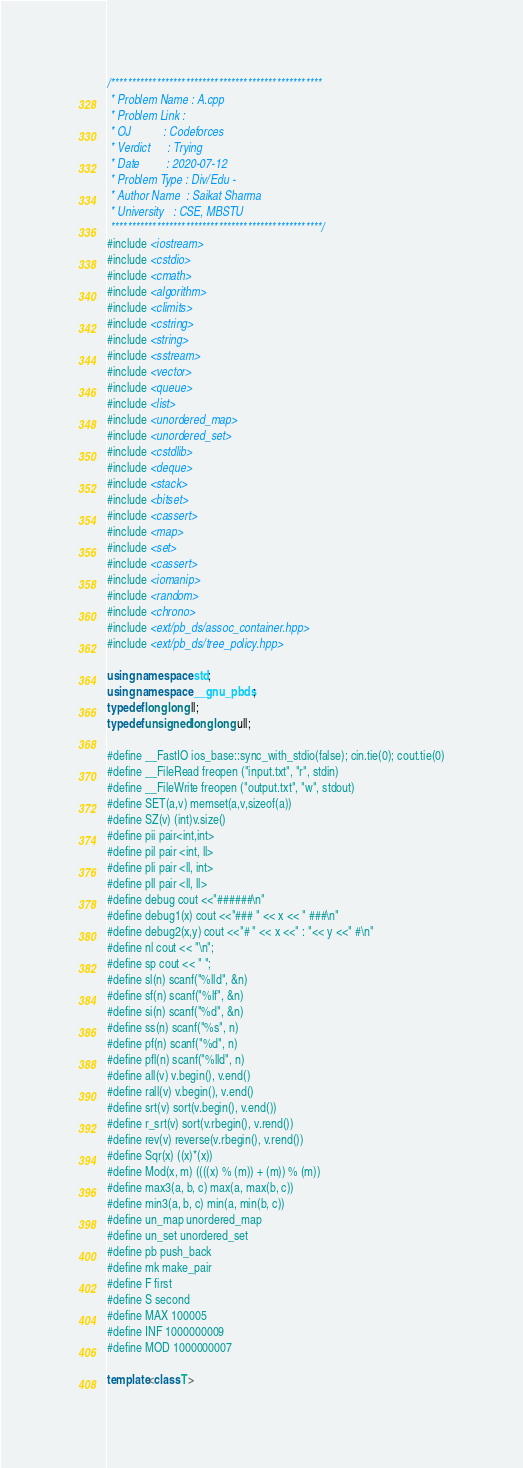Convert code to text. <code><loc_0><loc_0><loc_500><loc_500><_C++_>/***************************************************
 * Problem Name : A.cpp
 * Problem Link :
 * OJ           : Codeforces
 * Verdict      : Trying
 * Date         : 2020-07-12
 * Problem Type : Div/Edu -
 * Author Name  : Saikat Sharma
 * University   : CSE, MBSTU
 ***************************************************/
#include <iostream>
#include <cstdio>
#include <cmath>
#include <algorithm>
#include <climits>
#include <cstring>
#include <string>
#include <sstream>
#include <vector>
#include <queue>
#include <list>
#include <unordered_map>
#include <unordered_set>
#include <cstdlib>
#include <deque>
#include <stack>
#include <bitset>
#include <cassert>
#include <map>
#include <set>
#include <cassert>
#include <iomanip>
#include <random>
#include <chrono>
#include <ext/pb_ds/assoc_container.hpp>
#include <ext/pb_ds/tree_policy.hpp>

using namespace std;
using namespace __gnu_pbds;
typedef long long ll;
typedef unsigned long long ull;

#define __FastIO ios_base::sync_with_stdio(false); cin.tie(0); cout.tie(0)
#define __FileRead freopen ("input.txt", "r", stdin)
#define __FileWrite freopen ("output.txt", "w", stdout)
#define SET(a,v) memset(a,v,sizeof(a))
#define SZ(v) (int)v.size()
#define pii pair<int,int>
#define pil pair <int, ll>
#define pli pair <ll, int>
#define pll pair <ll, ll>
#define debug cout <<"######\n"
#define debug1(x) cout <<"### " << x << " ###\n"
#define debug2(x,y) cout <<"# " << x <<" : "<< y <<" #\n"
#define nl cout << "\n";
#define sp cout << " ";
#define sl(n) scanf("%lld", &n)
#define sf(n) scanf("%lf", &n)
#define si(n) scanf("%d", &n)
#define ss(n) scanf("%s", n)
#define pf(n) scanf("%d", n)
#define pfl(n) scanf("%lld", n)
#define all(v) v.begin(), v.end()
#define rall(v) v.begin(), v.end()
#define srt(v) sort(v.begin(), v.end())
#define r_srt(v) sort(v.rbegin(), v.rend())
#define rev(v) reverse(v.rbegin(), v.rend())
#define Sqr(x) ((x)*(x))
#define Mod(x, m) ((((x) % (m)) + (m)) % (m))
#define max3(a, b, c) max(a, max(b, c))
#define min3(a, b, c) min(a, min(b, c))
#define un_map unordered_map
#define un_set unordered_set
#define pb push_back
#define mk make_pair
#define F first
#define S second
#define MAX 100005
#define INF 1000000009
#define MOD 1000000007

template<class T></code> 